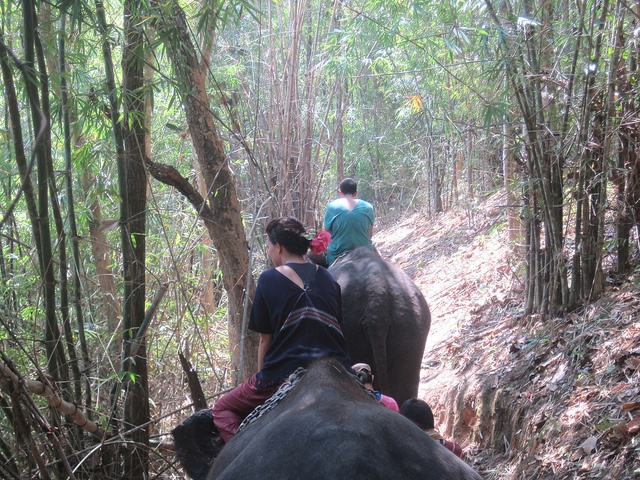Describe the objects in this image and their specific colors. I can see elephant in teal, gray, and black tones, people in teal, black, gray, and purple tones, elephant in teal, black, gray, and darkgray tones, people in teal and gray tones, and people in teal, black, gray, darkgray, and purple tones in this image. 